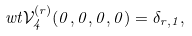Convert formula to latex. <formula><loc_0><loc_0><loc_500><loc_500>\ w t { \mathcal { V } } ^ { ( r ) } _ { 4 } ( 0 , 0 , 0 , 0 ) = \delta _ { r , 1 } ,</formula> 